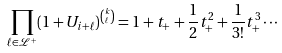<formula> <loc_0><loc_0><loc_500><loc_500>\prod _ { \ell \in \mathcal { L } ^ { + } } ( 1 + U _ { i + \ell } ) ^ { \binom { k } { \ell } } = 1 + t _ { + } + \frac { 1 } { 2 } t _ { + } ^ { 2 } + \frac { 1 } { 3 ! } t _ { + } ^ { 3 } \cdots</formula> 